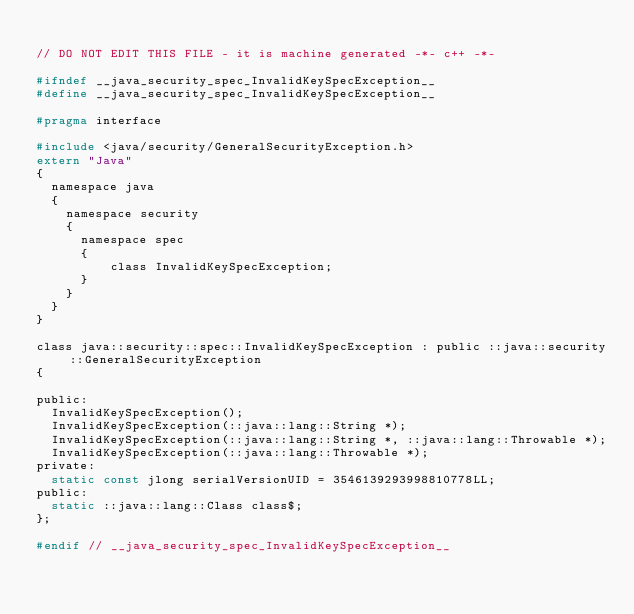<code> <loc_0><loc_0><loc_500><loc_500><_C_>
// DO NOT EDIT THIS FILE - it is machine generated -*- c++ -*-

#ifndef __java_security_spec_InvalidKeySpecException__
#define __java_security_spec_InvalidKeySpecException__

#pragma interface

#include <java/security/GeneralSecurityException.h>
extern "Java"
{
  namespace java
  {
    namespace security
    {
      namespace spec
      {
          class InvalidKeySpecException;
      }
    }
  }
}

class java::security::spec::InvalidKeySpecException : public ::java::security::GeneralSecurityException
{

public:
  InvalidKeySpecException();
  InvalidKeySpecException(::java::lang::String *);
  InvalidKeySpecException(::java::lang::String *, ::java::lang::Throwable *);
  InvalidKeySpecException(::java::lang::Throwable *);
private:
  static const jlong serialVersionUID = 3546139293998810778LL;
public:
  static ::java::lang::Class class$;
};

#endif // __java_security_spec_InvalidKeySpecException__
</code> 